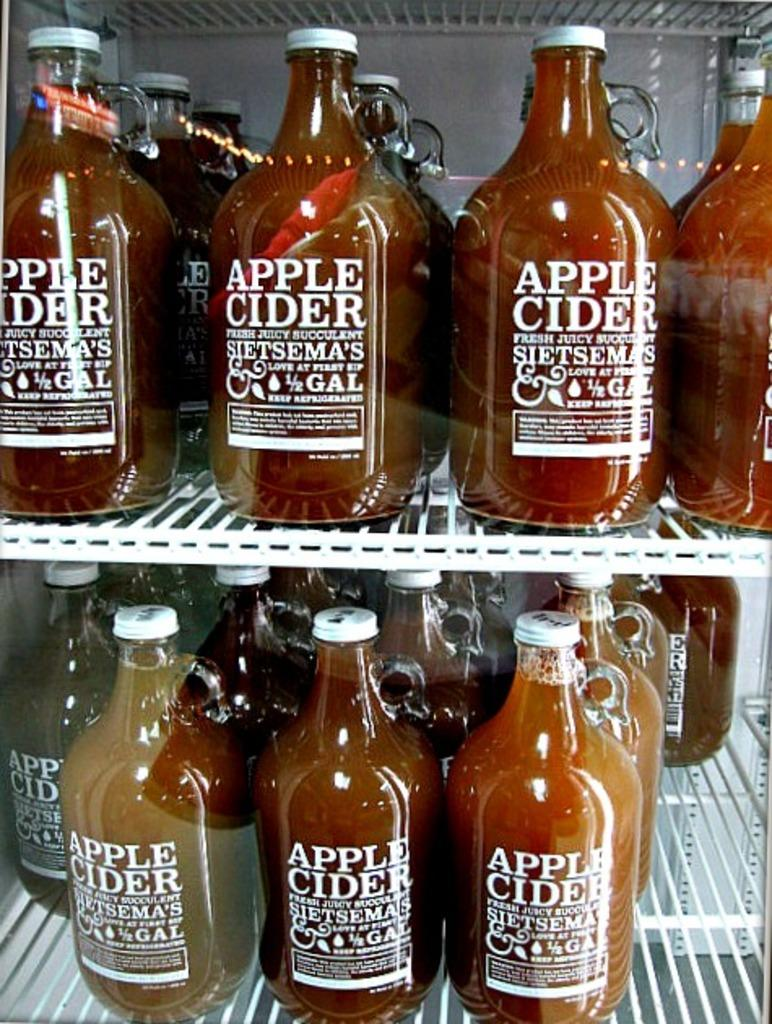<image>
Create a compact narrative representing the image presented. Rows of aple cider placed inside a glass fridge. 